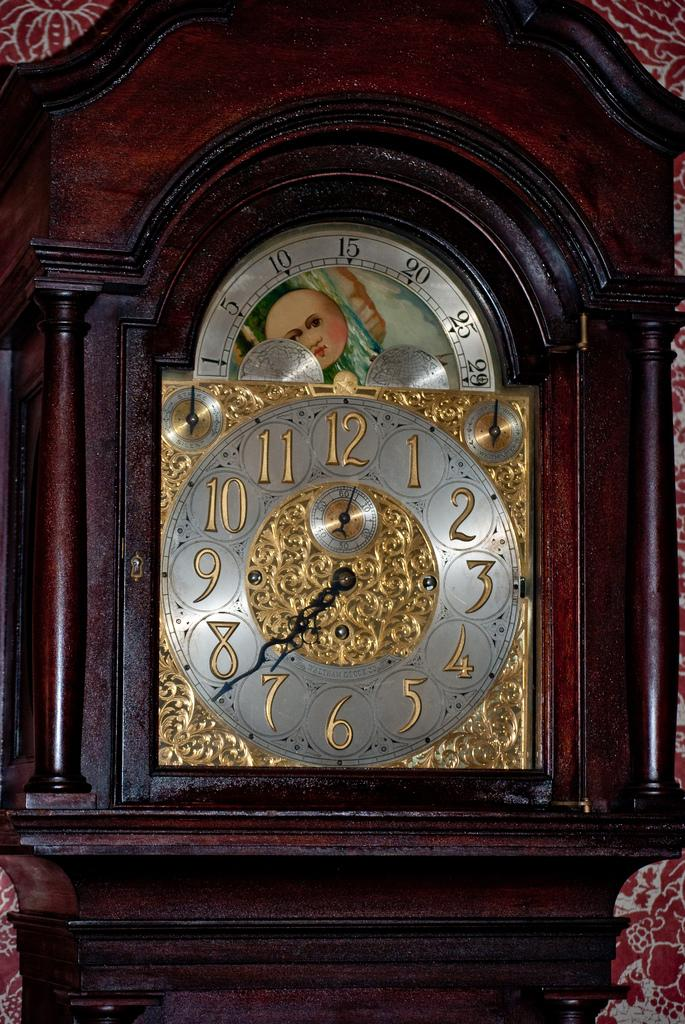What object in the image can be used to tell time? There is a wall clock in the image that can be used to tell time. What can be seen in the background of the image? There is a designed wall in the background of the image. How many boys are playing with the plant and flowers in the image? There are no boys, plants, or flowers present in the image. 